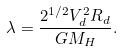<formula> <loc_0><loc_0><loc_500><loc_500>\lambda = \frac { 2 ^ { 1 / 2 } V _ { d } ^ { 2 } R _ { d } } { G M _ { H } } .</formula> 